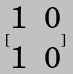<formula> <loc_0><loc_0><loc_500><loc_500>[ \begin{matrix} 1 & 0 \\ 1 & 0 \end{matrix} ]</formula> 